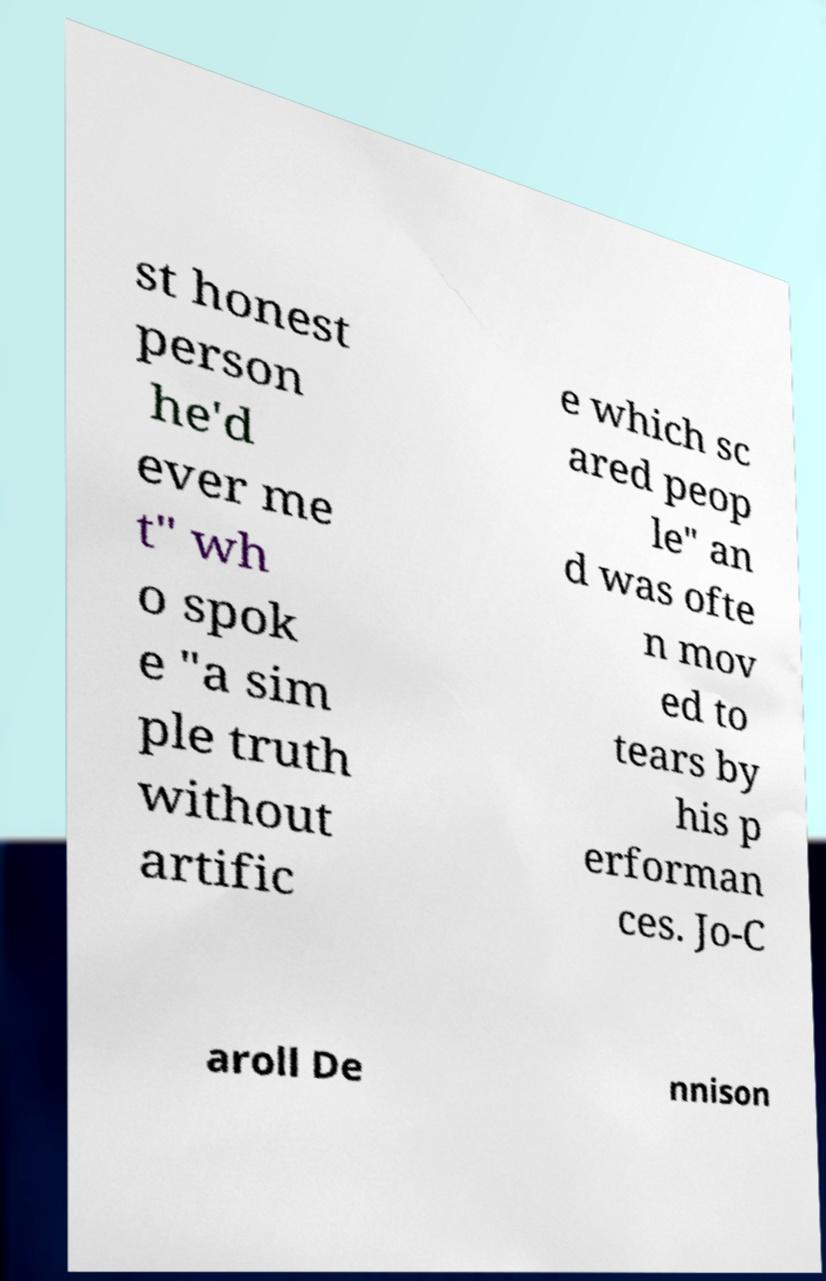What messages or text are displayed in this image? I need them in a readable, typed format. st honest person he'd ever me t" wh o spok e "a sim ple truth without artific e which sc ared peop le" an d was ofte n mov ed to tears by his p erforman ces. Jo-C aroll De nnison 